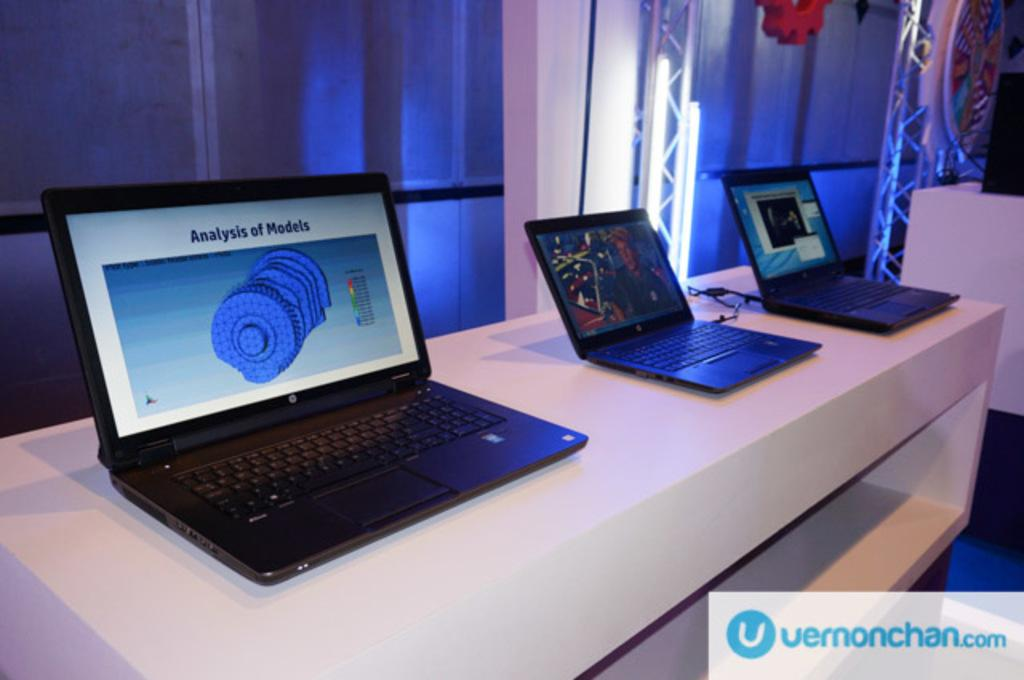Provide a one-sentence caption for the provided image. Three laptops on a table, one with "Analysis of Models" on the screen. 